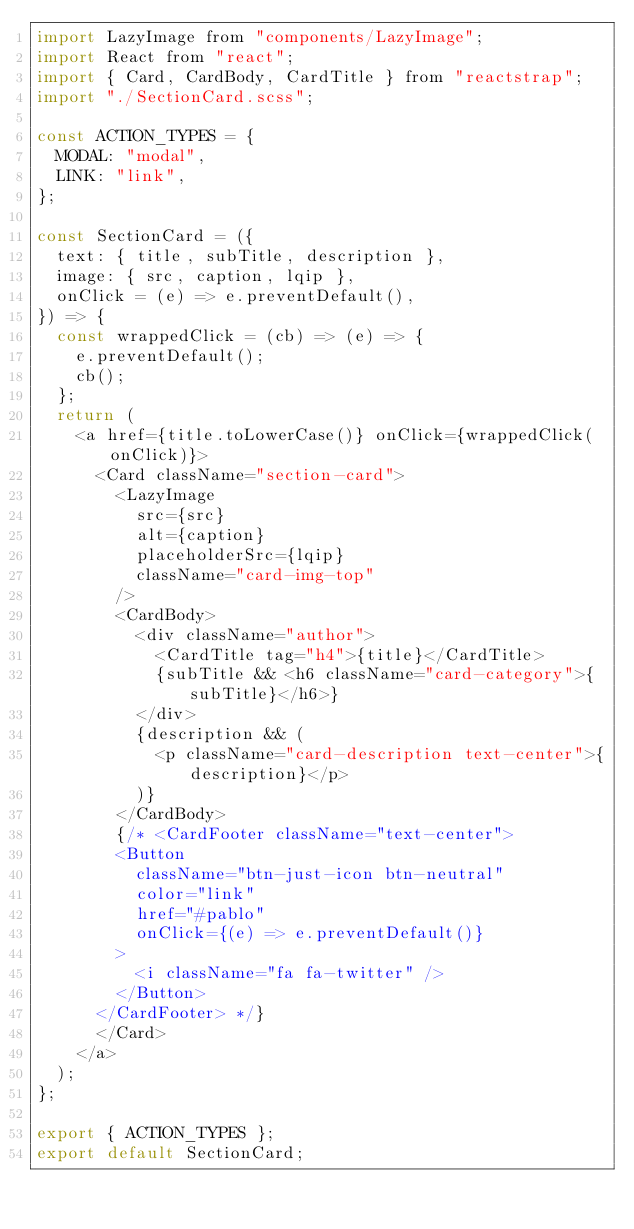Convert code to text. <code><loc_0><loc_0><loc_500><loc_500><_JavaScript_>import LazyImage from "components/LazyImage";
import React from "react";
import { Card, CardBody, CardTitle } from "reactstrap";
import "./SectionCard.scss";

const ACTION_TYPES = {
  MODAL: "modal",
  LINK: "link",
};

const SectionCard = ({
  text: { title, subTitle, description },
  image: { src, caption, lqip },
  onClick = (e) => e.preventDefault(),
}) => {
  const wrappedClick = (cb) => (e) => {
    e.preventDefault();
    cb();
  };
  return (
    <a href={title.toLowerCase()} onClick={wrappedClick(onClick)}>
      <Card className="section-card">
        <LazyImage
          src={src}
          alt={caption}
          placeholderSrc={lqip}
          className="card-img-top"
        />
        <CardBody>
          <div className="author">
            <CardTitle tag="h4">{title}</CardTitle>
            {subTitle && <h6 className="card-category">{subTitle}</h6>}
          </div>
          {description && (
            <p className="card-description text-center">{description}</p>
          )}
        </CardBody>
        {/* <CardFooter className="text-center">
        <Button
          className="btn-just-icon btn-neutral"
          color="link"
          href="#pablo"
          onClick={(e) => e.preventDefault()}
        >
          <i className="fa fa-twitter" />
        </Button>
      </CardFooter> */}
      </Card>
    </a>
  );
};

export { ACTION_TYPES };
export default SectionCard;
</code> 